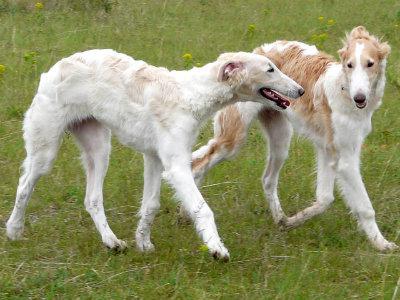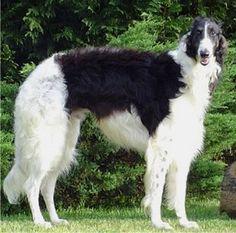The first image is the image on the left, the second image is the image on the right. For the images displayed, is the sentence "All images show hounds standing on the grass." factually correct? Answer yes or no. Yes. The first image is the image on the left, the second image is the image on the right. For the images shown, is this caption "All of the dogs are facing the same way." true? Answer yes or no. Yes. 